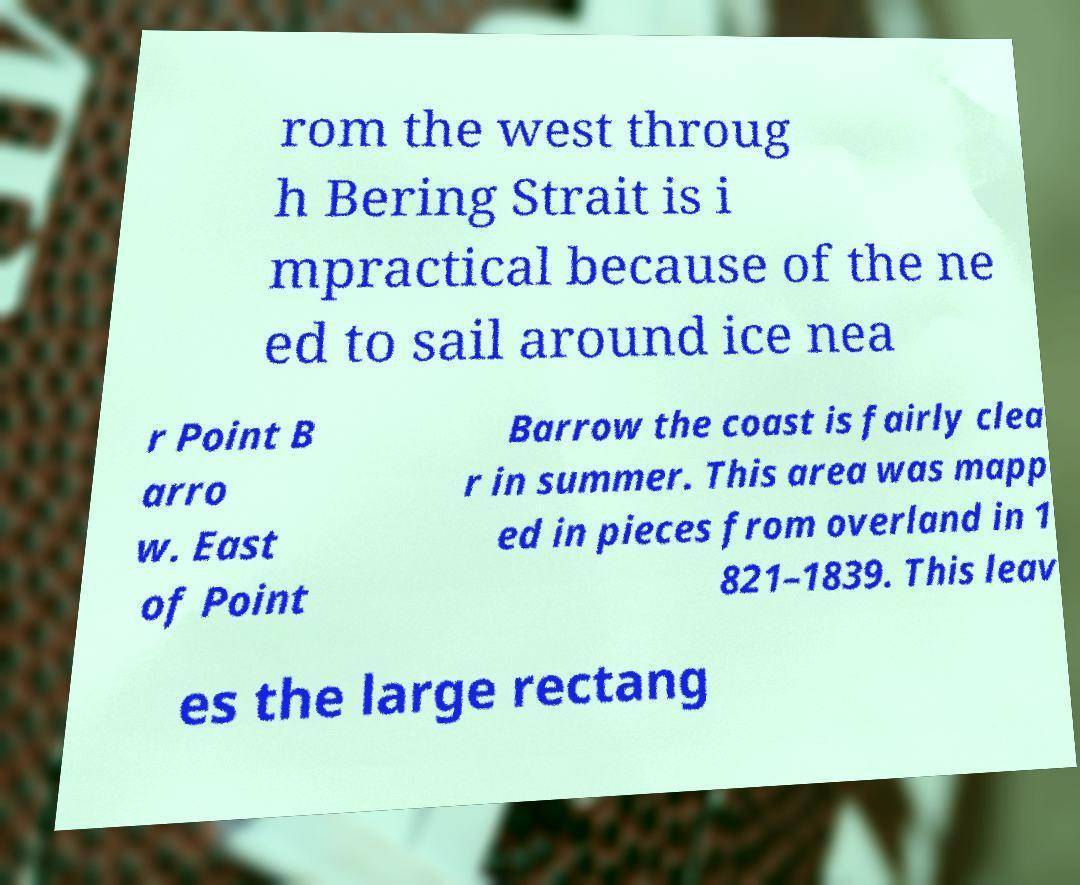Please identify and transcribe the text found in this image. rom the west throug h Bering Strait is i mpractical because of the ne ed to sail around ice nea r Point B arro w. East of Point Barrow the coast is fairly clea r in summer. This area was mapp ed in pieces from overland in 1 821–1839. This leav es the large rectang 